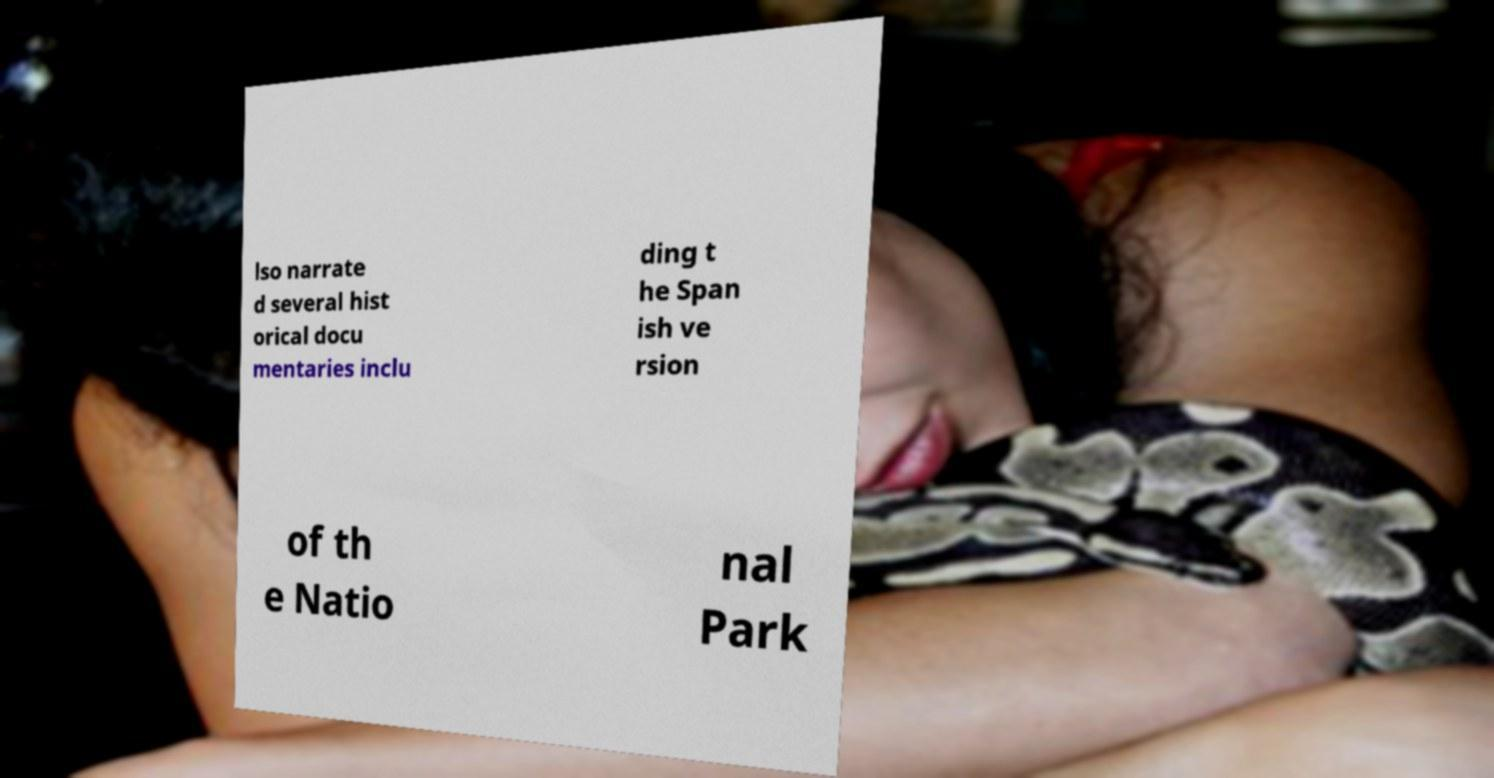What messages or text are displayed in this image? I need them in a readable, typed format. lso narrate d several hist orical docu mentaries inclu ding t he Span ish ve rsion of th e Natio nal Park 